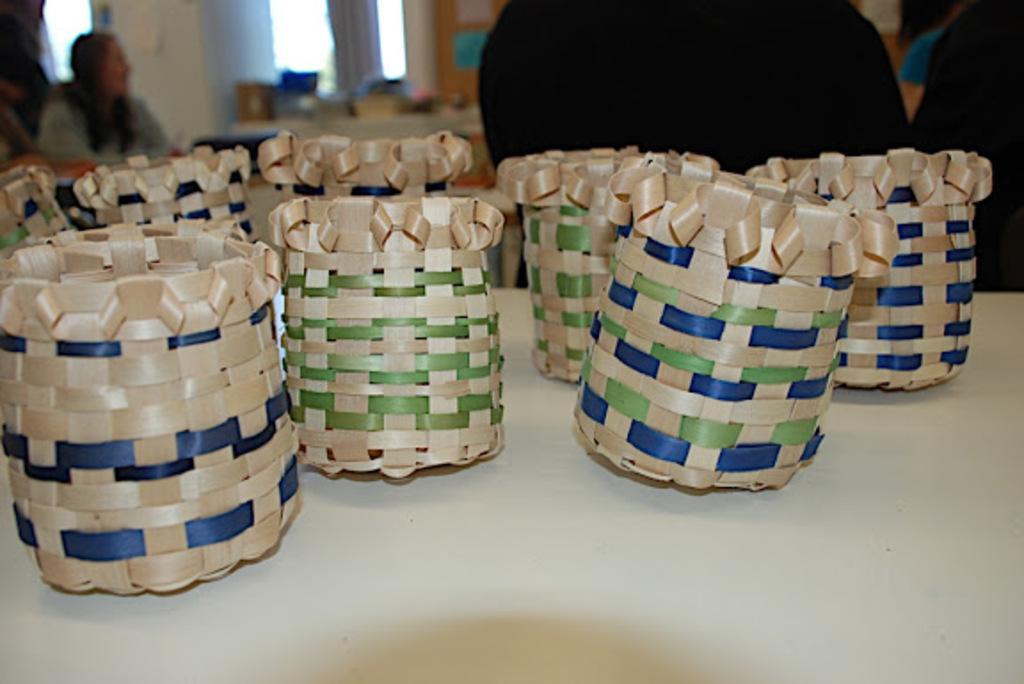Please provide a concise description of this image. In this image at the bottom there is a table, and on the table there are some baskets. And in the background there are some persons, window, table and some other objects. 